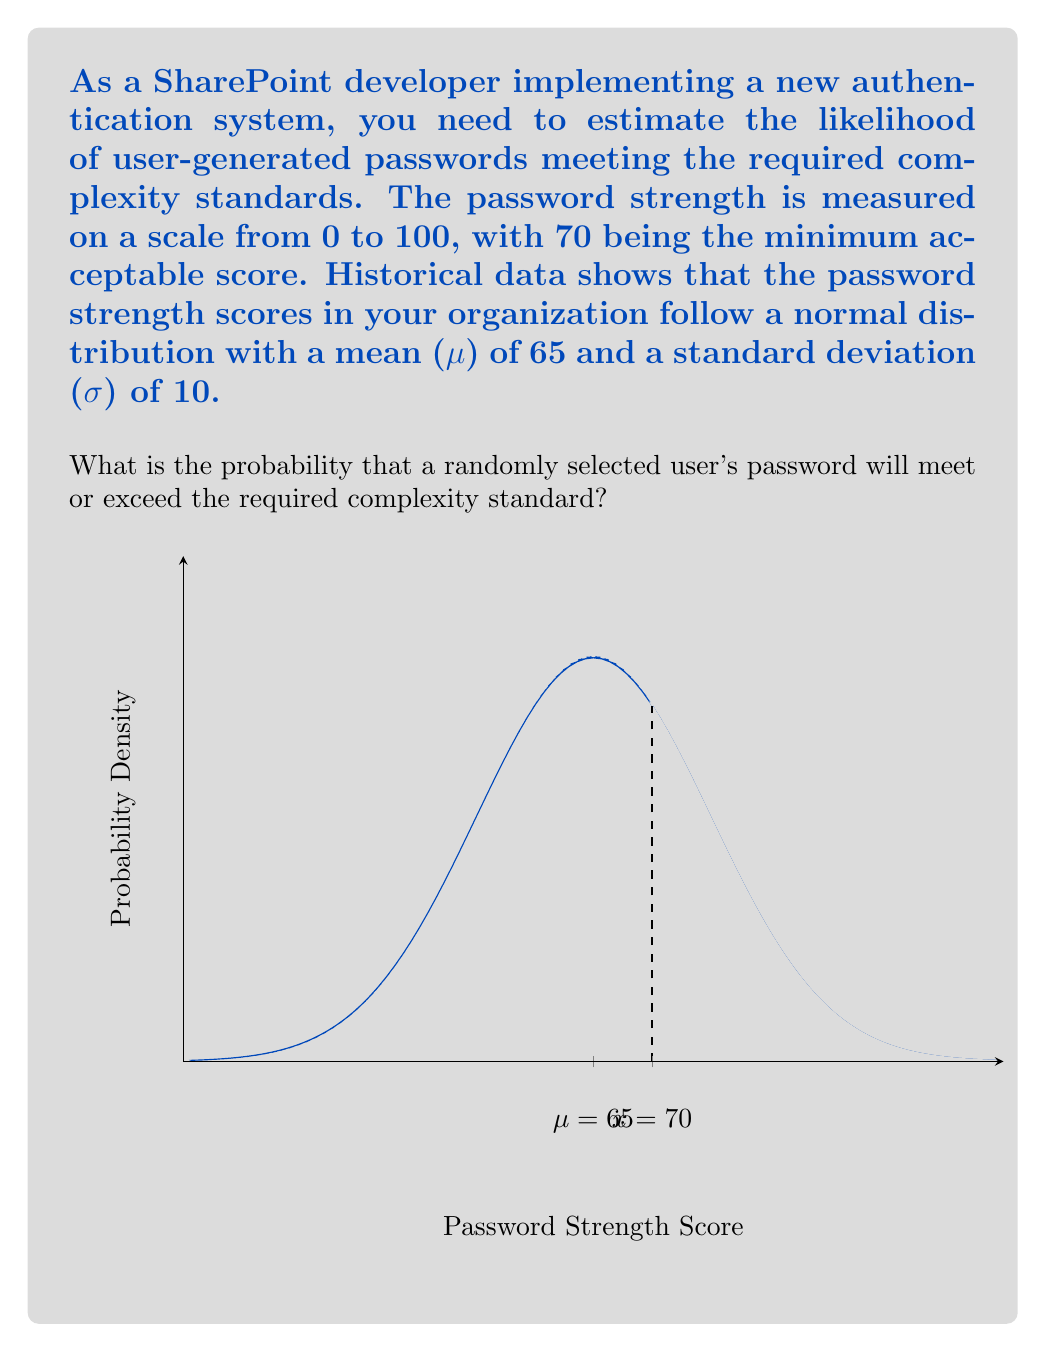Solve this math problem. To solve this problem, we need to use the properties of the normal distribution and calculate the z-score for the given threshold. Then, we'll use the standard normal distribution table or the complementary error function to find the probability.

Step 1: Calculate the z-score
The z-score represents how many standard deviations the threshold is from the mean.

$$ z = \frac{x - \mu}{\sigma} $$

Where:
x = 70 (minimum acceptable score)
μ = 65 (mean)
σ = 10 (standard deviation)

$$ z = \frac{70 - 65}{10} = 0.5 $$

Step 2: Calculate the probability
We need to find P(X ≥ 70), which is equivalent to finding the area under the standard normal curve to the right of z = 0.5.

Using the complementary error function (erfc), we can calculate this probability:

$$ P(X \geq 70) = \frac{1}{2} \text{erfc}\left(\frac{z}{\sqrt{2}}\right) $$

$$ P(X \geq 70) = \frac{1}{2} \text{erfc}\left(\frac{0.5}{\sqrt{2}}\right) \approx 0.3085 $$

Therefore, the probability that a randomly selected user's password will meet or exceed the required complexity standard is approximately 0.3085 or 30.85%.
Answer: 0.3085 (or 30.85%) 